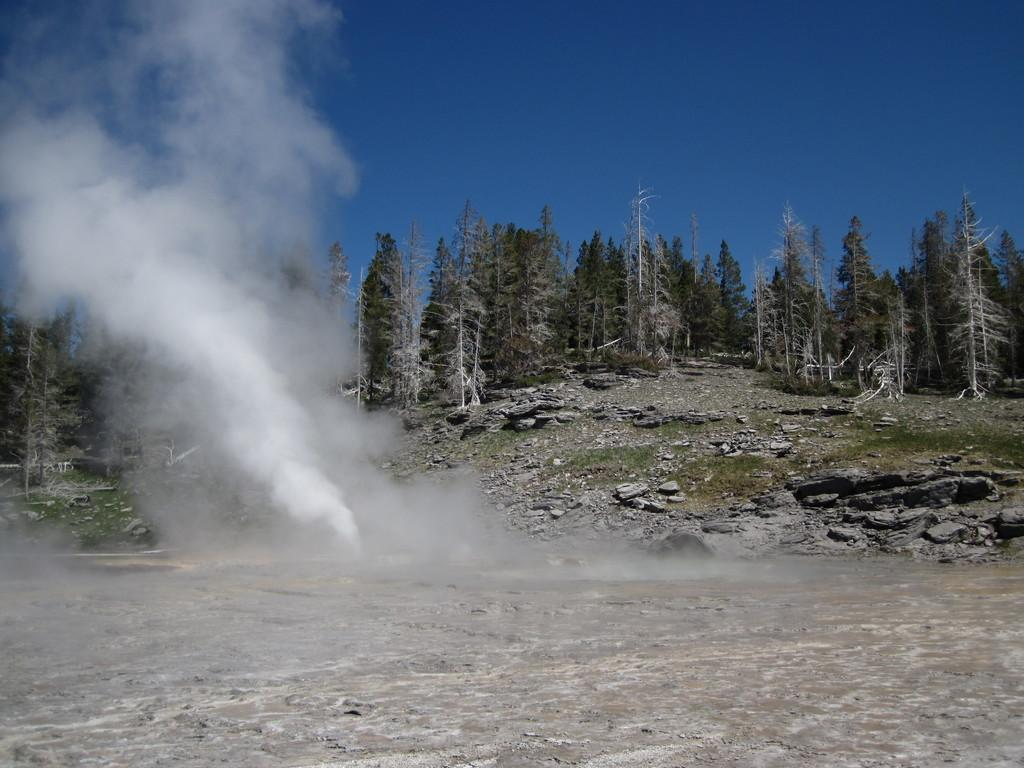What type of vegetation can be seen in the image? There are trees in the image. What else is visible in the image besides the trees? There is smoke and stones visible in the image. What is the color of the sky in the image? The sky is blue in color. Where is the book located in the image? There is no book present in the image. Can you see any icicles hanging from the trees in the image? There are no icicles visible in the image; it is not cold enough for icicles to form. 